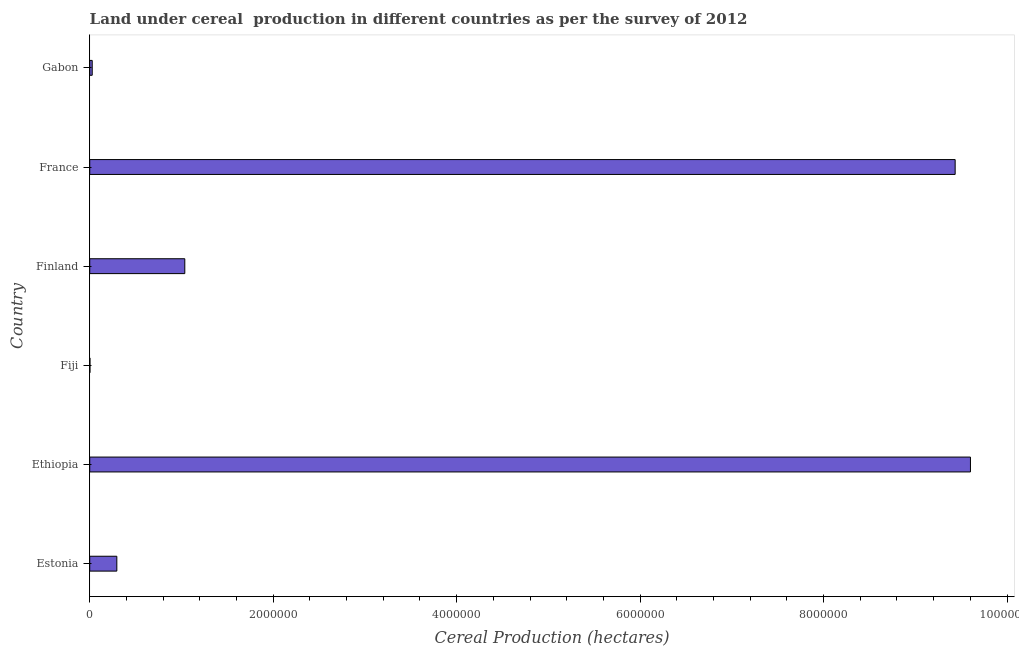Does the graph contain any zero values?
Ensure brevity in your answer.  No. What is the title of the graph?
Make the answer very short. Land under cereal  production in different countries as per the survey of 2012. What is the label or title of the X-axis?
Offer a very short reply. Cereal Production (hectares). What is the label or title of the Y-axis?
Your answer should be compact. Country. What is the land under cereal production in Estonia?
Keep it short and to the point. 2.95e+05. Across all countries, what is the maximum land under cereal production?
Provide a succinct answer. 9.60e+06. Across all countries, what is the minimum land under cereal production?
Your response must be concise. 2491. In which country was the land under cereal production maximum?
Your response must be concise. Ethiopia. In which country was the land under cereal production minimum?
Your answer should be very brief. Fiji. What is the sum of the land under cereal production?
Give a very brief answer. 2.04e+07. What is the difference between the land under cereal production in Estonia and France?
Your answer should be compact. -9.14e+06. What is the average land under cereal production per country?
Your response must be concise. 3.40e+06. What is the median land under cereal production?
Provide a succinct answer. 6.66e+05. What is the ratio of the land under cereal production in Estonia to that in France?
Offer a terse response. 0.03. Is the difference between the land under cereal production in Fiji and Finland greater than the difference between any two countries?
Provide a succinct answer. No. What is the difference between the highest and the second highest land under cereal production?
Keep it short and to the point. 1.67e+05. What is the difference between the highest and the lowest land under cereal production?
Your response must be concise. 9.60e+06. How many countries are there in the graph?
Offer a terse response. 6. Are the values on the major ticks of X-axis written in scientific E-notation?
Your answer should be very brief. No. What is the Cereal Production (hectares) in Estonia?
Your response must be concise. 2.95e+05. What is the Cereal Production (hectares) of Ethiopia?
Your answer should be compact. 9.60e+06. What is the Cereal Production (hectares) in Fiji?
Your answer should be compact. 2491. What is the Cereal Production (hectares) in Finland?
Offer a terse response. 1.04e+06. What is the Cereal Production (hectares) of France?
Give a very brief answer. 9.43e+06. What is the Cereal Production (hectares) in Gabon?
Your answer should be compact. 2.71e+04. What is the difference between the Cereal Production (hectares) in Estonia and Ethiopia?
Keep it short and to the point. -9.31e+06. What is the difference between the Cereal Production (hectares) in Estonia and Fiji?
Ensure brevity in your answer.  2.93e+05. What is the difference between the Cereal Production (hectares) in Estonia and Finland?
Offer a very short reply. -7.41e+05. What is the difference between the Cereal Production (hectares) in Estonia and France?
Offer a terse response. -9.14e+06. What is the difference between the Cereal Production (hectares) in Estonia and Gabon?
Give a very brief answer. 2.68e+05. What is the difference between the Cereal Production (hectares) in Ethiopia and Fiji?
Give a very brief answer. 9.60e+06. What is the difference between the Cereal Production (hectares) in Ethiopia and Finland?
Provide a short and direct response. 8.56e+06. What is the difference between the Cereal Production (hectares) in Ethiopia and France?
Ensure brevity in your answer.  1.67e+05. What is the difference between the Cereal Production (hectares) in Ethiopia and Gabon?
Keep it short and to the point. 9.57e+06. What is the difference between the Cereal Production (hectares) in Fiji and Finland?
Your answer should be compact. -1.03e+06. What is the difference between the Cereal Production (hectares) in Fiji and France?
Make the answer very short. -9.43e+06. What is the difference between the Cereal Production (hectares) in Fiji and Gabon?
Your answer should be compact. -2.46e+04. What is the difference between the Cereal Production (hectares) in Finland and France?
Your answer should be very brief. -8.40e+06. What is the difference between the Cereal Production (hectares) in Finland and Gabon?
Offer a very short reply. 1.01e+06. What is the difference between the Cereal Production (hectares) in France and Gabon?
Your response must be concise. 9.41e+06. What is the ratio of the Cereal Production (hectares) in Estonia to that in Ethiopia?
Provide a succinct answer. 0.03. What is the ratio of the Cereal Production (hectares) in Estonia to that in Fiji?
Your answer should be very brief. 118.58. What is the ratio of the Cereal Production (hectares) in Estonia to that in Finland?
Your answer should be very brief. 0.28. What is the ratio of the Cereal Production (hectares) in Estonia to that in France?
Your response must be concise. 0.03. What is the ratio of the Cereal Production (hectares) in Estonia to that in Gabon?
Provide a succinct answer. 10.89. What is the ratio of the Cereal Production (hectares) in Ethiopia to that in Fiji?
Keep it short and to the point. 3854.29. What is the ratio of the Cereal Production (hectares) in Ethiopia to that in Finland?
Offer a very short reply. 9.27. What is the ratio of the Cereal Production (hectares) in Ethiopia to that in Gabon?
Ensure brevity in your answer.  354.02. What is the ratio of the Cereal Production (hectares) in Fiji to that in Finland?
Your answer should be very brief. 0. What is the ratio of the Cereal Production (hectares) in Fiji to that in France?
Keep it short and to the point. 0. What is the ratio of the Cereal Production (hectares) in Fiji to that in Gabon?
Your response must be concise. 0.09. What is the ratio of the Cereal Production (hectares) in Finland to that in France?
Your answer should be very brief. 0.11. What is the ratio of the Cereal Production (hectares) in Finland to that in Gabon?
Make the answer very short. 38.21. What is the ratio of the Cereal Production (hectares) in France to that in Gabon?
Offer a terse response. 347.87. 